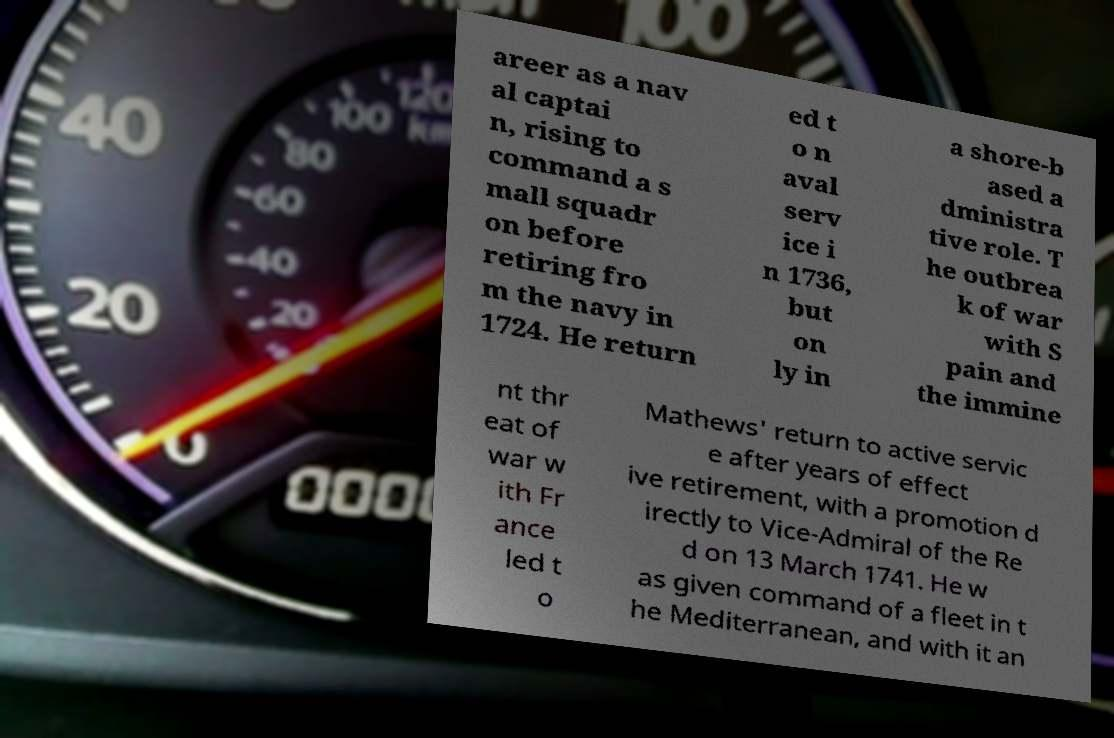Can you read and provide the text displayed in the image?This photo seems to have some interesting text. Can you extract and type it out for me? areer as a nav al captai n, rising to command a s mall squadr on before retiring fro m the navy in 1724. He return ed t o n aval serv ice i n 1736, but on ly in a shore-b ased a dministra tive role. T he outbrea k of war with S pain and the immine nt thr eat of war w ith Fr ance led t o Mathews' return to active servic e after years of effect ive retirement, with a promotion d irectly to Vice-Admiral of the Re d on 13 March 1741. He w as given command of a fleet in t he Mediterranean, and with it an 